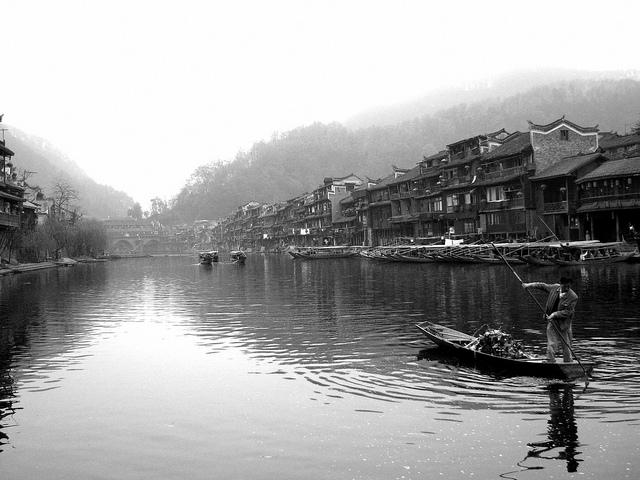Is the boat called a gondola?
Answer briefly. Yes. What kind of boats are these?
Be succinct. Canoe. What is this person doing?
Answer briefly. Rowing. Is the image in black and white?
Quick response, please. Yes. How many people are there?
Short answer required. 1. Are the people in a lake?
Keep it brief. No. 